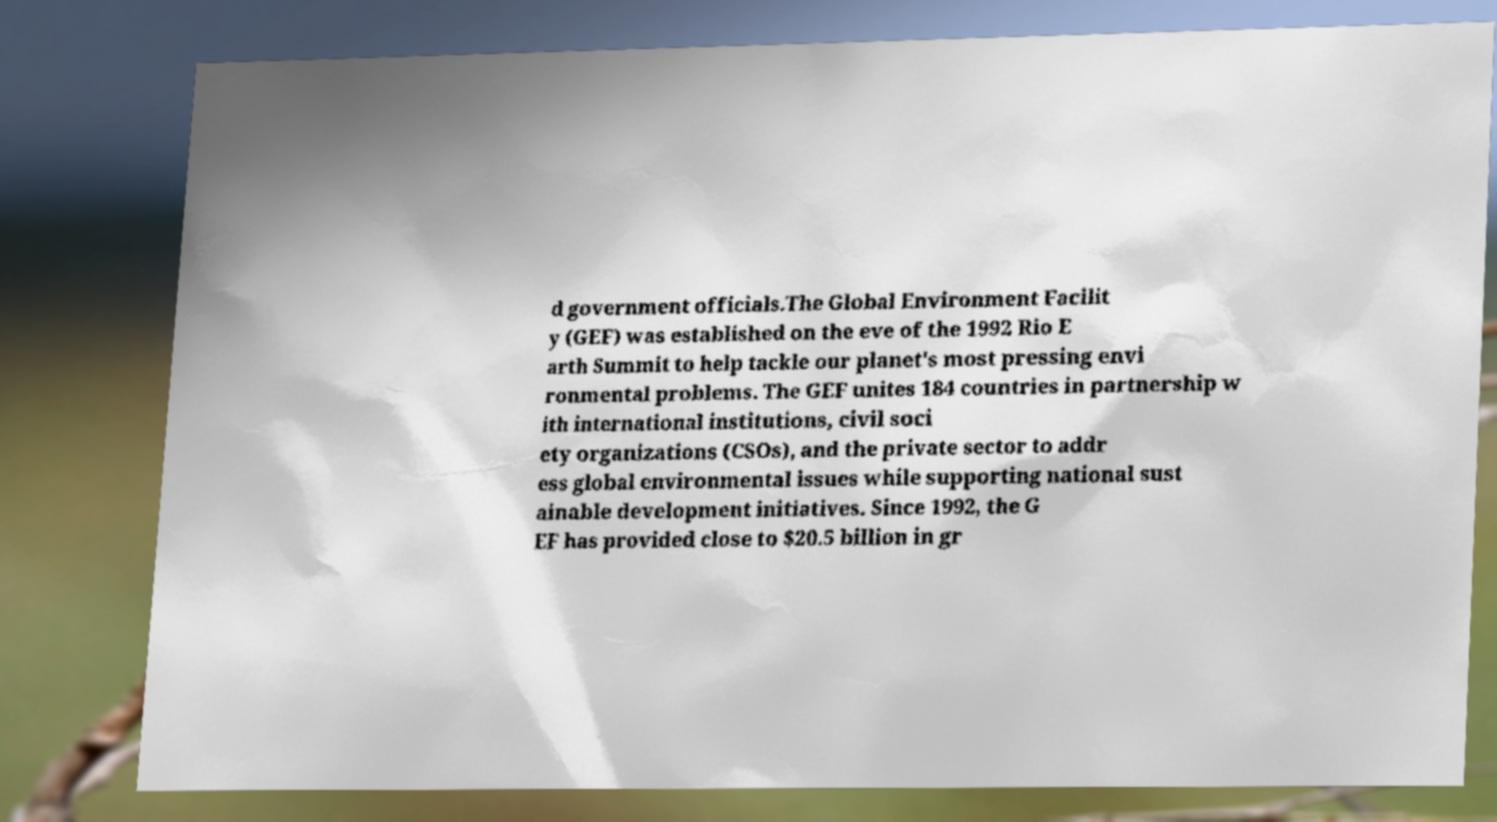I need the written content from this picture converted into text. Can you do that? d government officials.The Global Environment Facilit y (GEF) was established on the eve of the 1992 Rio E arth Summit to help tackle our planet's most pressing envi ronmental problems. The GEF unites 184 countries in partnership w ith international institutions, civil soci ety organizations (CSOs), and the private sector to addr ess global environmental issues while supporting national sust ainable development initiatives. Since 1992, the G EF has provided close to $20.5 billion in gr 